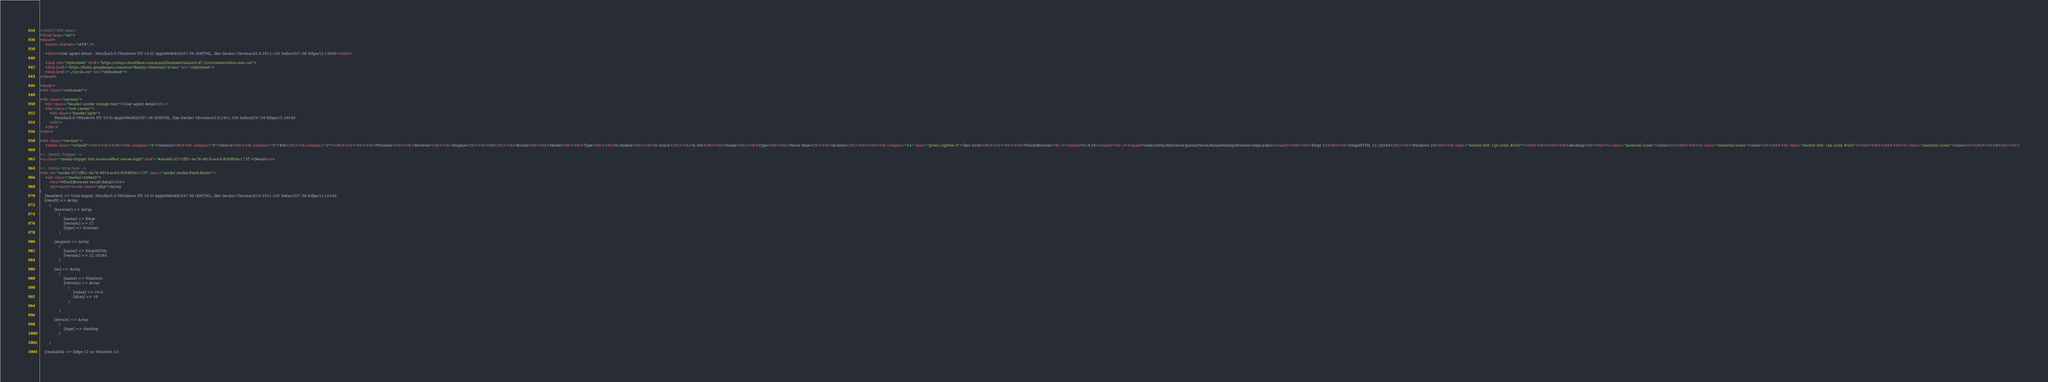Convert code to text. <code><loc_0><loc_0><loc_500><loc_500><_HTML_>
<!DOCTYPE html>
<html lang="en">
<head>
    <meta charset="utf-8" />
            
    <title>User agent detail - Mozilla/5.0 (Windows NT 10.0) AppleWebKit/537.36 (KHTML, like Gecko) Chrome/42.0.2311.135 Safari/537.36 Edge/12.10240</title>
        
    <link rel="stylesheet" href="https://cdnjs.cloudflare.com/ajax/libs/materialize/0.97.3/css/materialize.min.css">
    <link href="https://fonts.googleapis.com/icon?family=Material+Icons" rel="stylesheet">
    <link href="../circle.css" rel="stylesheet">
</head>
        
<body>
<div class="container">
    
<div class="section">
	<h1 class="header center orange-text">User agent detail</h1>
	<div class="row center">
        <h5 class="header light">
            Mozilla/5.0 (Windows NT 10.0) AppleWebKit/537.36 (KHTML, like Gecko) Chrome/42.0.2311.135 Safari/537.36 Edge/12.10240
        </h5>
	</div>
</div>   

<div class="section">
    <table class="striped"><tr><th></th><th colspan="3">General</th><th colspan="5">Device</th><th colspan="3">Bot</th><th colspan="2"></th></tr><tr><th>Provider</th><th>Browser</th><th>Engine</th><th>OS</th><th>Brand</th><th>Model</th><th>Type</th><th>Is mobile</th><th>Is touch</th><th>Is bot</th><th>Name</th><th>Type</th><th>Parse time</th><th>Actions</th></tr><tr><th colspan="14" class="green lighten-3">Test suite</th></tr><tr><td>WhichBrowser<br /><small>v2.0.18</small><br /><small>vendor/whichbrowser/parser/tests/data/desktop/browser-edge.yaml</small></td><td>Edge 12</td><td>EdgeHTML 12.10240</td><td>Windows 10</td><td style="border-left: 1px solid #555"></td><td></td><td>desktop</td><td><i class="material-icons">close</i></td><td><i class="material-icons">close</i></td><td style="border-left: 1px solid #555"></td><td></td><td><i class="material-icons">close</i></td><td>0</td><td>
        
<!-- Modal Trigger -->
<a class="modal-trigger btn waves-effect waves-light" href="#modal-027cff01-4a76-491b-ace3-9289fcbc172f">Detail</a>
        
<!-- Modal Structure -->
<div id="modal-027cff01-4a76-491b-ace3-9289fcbc172f" class="modal modal-fixed-footer">
    <div class="modal-content">
        <h4>WhichBrowser result detail</h4>
        <p><pre><code class="php">Array
(
    [headers] => User-Agent: Mozilla/5.0 (Windows NT 10.0) AppleWebKit/537.36 (KHTML, like Gecko) Chrome/42.0.2311.135 Safari/537.36 Edge/12.10240
    [result] => Array
        (
            [browser] => Array
                (
                    [name] => Edge
                    [version] => 12
                    [type] => browser
                )

            [engine] => Array
                (
                    [name] => EdgeHTML
                    [version] => 12.10240
                )

            [os] => Array
                (
                    [name] => Windows
                    [version] => Array
                        (
                            [value] => 10.0
                            [alias] => 10
                        )

                )

            [device] => Array
                (
                    [type] => desktop
                )

        )

    [readable] => Edge 12 on Windows 10</code> 